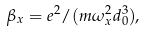Convert formula to latex. <formula><loc_0><loc_0><loc_500><loc_500>\beta _ { x } = e ^ { 2 } / ( m \omega _ { x } ^ { 2 } d ^ { 3 } _ { 0 } ) ,</formula> 